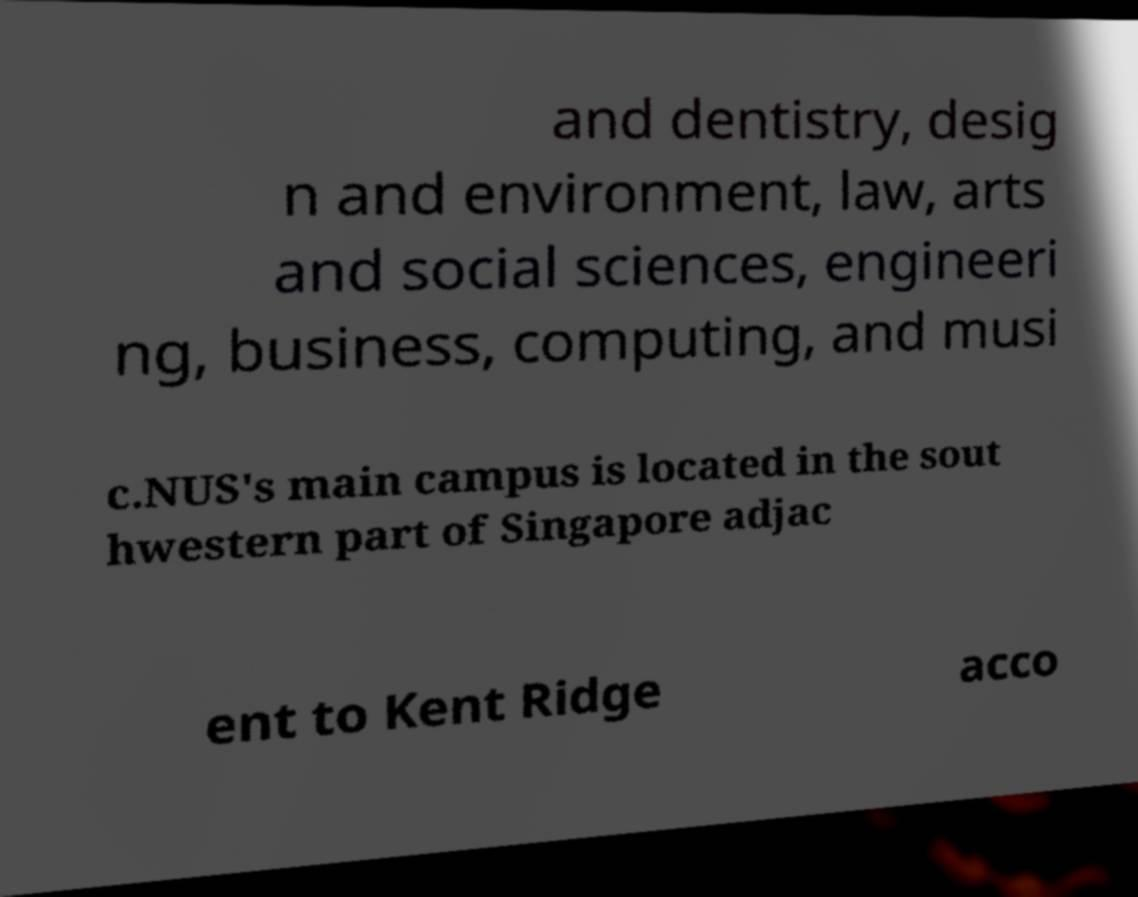Please read and relay the text visible in this image. What does it say? and dentistry, desig n and environment, law, arts and social sciences, engineeri ng, business, computing, and musi c.NUS's main campus is located in the sout hwestern part of Singapore adjac ent to Kent Ridge acco 